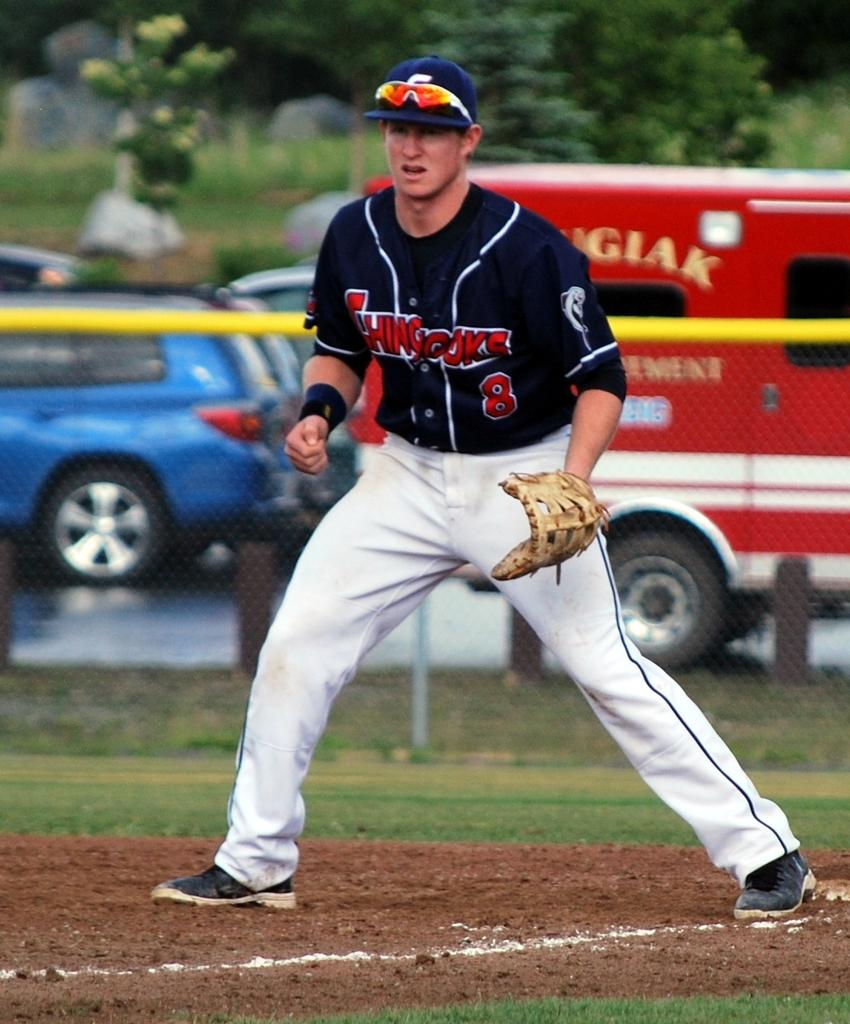What is the main subject of the image? There is a person on the ground in the image. What can be seen in the background of the image? There are vehicles and trees in the background of the image. What type of coil is being used by the person in the image? There is no coil present in the image; it features a person on the ground and vehicles and trees in the background. 